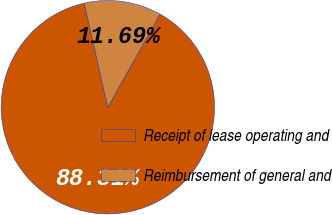Convert chart. <chart><loc_0><loc_0><loc_500><loc_500><pie_chart><fcel>Receipt of lease operating and<fcel>Reimbursement of general and<nl><fcel>88.31%<fcel>11.69%<nl></chart> 